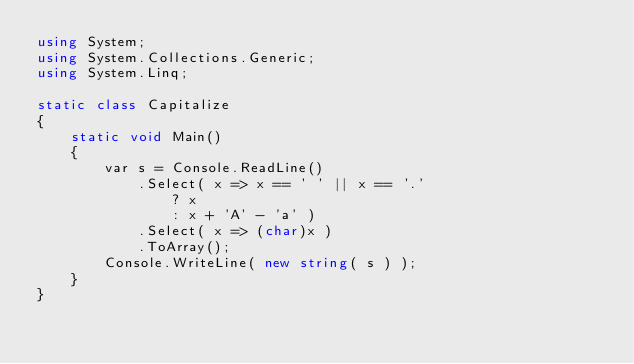Convert code to text. <code><loc_0><loc_0><loc_500><loc_500><_C#_>using System;
using System.Collections.Generic;
using System.Linq;

static class Capitalize
{
    static void Main()
    {
        var s = Console.ReadLine()
            .Select( x => x == ' ' || x == '.'
                ? x
                : x + 'A' - 'a' )
            .Select( x => (char)x )
            .ToArray();
        Console.WriteLine( new string( s ) );
    }
}</code> 